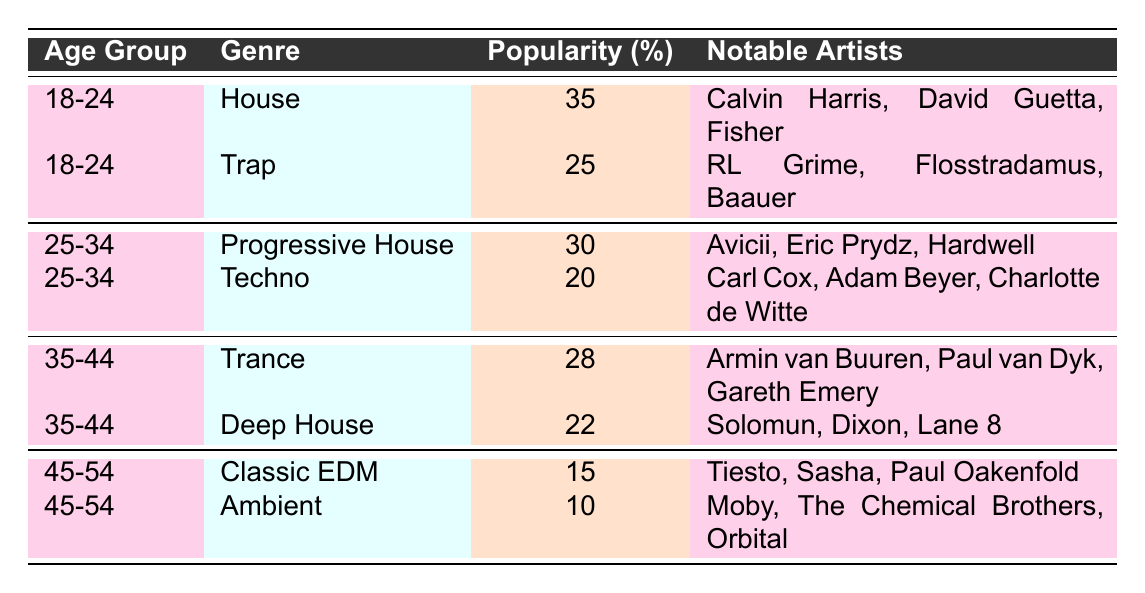What is the most popular EDM genre among the 18-24 age group? The table shows that the House genre has the highest popularity percentage of 35% within the 18-24 age group.
Answer: House Which age group shows the highest popularity for Trap? The table indicates that the Trap genre is popular at 25% only in the 18-24 age group, and there are no other age groups listed for Trap.
Answer: 18-24 What percentage of 25-34 year-olds prefer Techno compared to Progressive House? The popularity percentage for Progressive House is 30% and for Techno it is 20%, so tech is 10% less popular than Progressive House (30 - 20).
Answer: 10% Is the popularity of Classic EDM higher than Ambient in the 45-54 age group? Classic EDM has a popularity percentage of 15%, while Ambient's popularity is 10%. Since 15% is greater than 10%, the statement is true.
Answer: Yes Which genre has more notable artists listed in the 35-44 age group: Trance or Deep House? Both Trance and Deep House have three notable artists listed as follows: Trance has Armin van Buuren, Paul van Dyk, and Gareth Emery while Deep House has Solomun, Dixon, and Lane 8. Therefore, they have equal numbers of artists.
Answer: Equal What is the overall popularity percentage of EDM genres for age groups 45-54? Summing the popularity percentages for the genres in the 45-54 age group gives 15% (Classic EDM) + 10% (Ambient) = 25%.
Answer: 25% In which age group does the genre Trap appear, and what is its popularity percentage? Trap appears only in the 18-24 age group with a popularity percentage of 25%.
Answer: 18-24, 25% Which genre is equally popular among both 35-44 and 25-34 age groups and what is the popularity percentage? No genre is listed with the same popularity percentage in both age groups, as Techno (20%) and Trance (28%) differ from the genres in the 25-34 age group; therefore, there is no equality.
Answer: None What is the total number of notable artists across all the genres listed? Each genre has three notable artists, and there are six genres listed (House, Trap, Progressive House, Techno, Trance, Deep House, Classic EDM, and Ambient), yielding 3 artists x 8 genres = 24 notable artists in total.
Answer: 24 